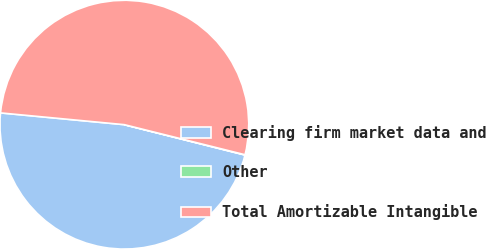<chart> <loc_0><loc_0><loc_500><loc_500><pie_chart><fcel>Clearing firm market data and<fcel>Other<fcel>Total Amortizable Intangible<nl><fcel>47.58%<fcel>0.04%<fcel>52.38%<nl></chart> 